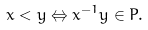<formula> <loc_0><loc_0><loc_500><loc_500>x < y \Leftrightarrow x ^ { - 1 } y \in P .</formula> 